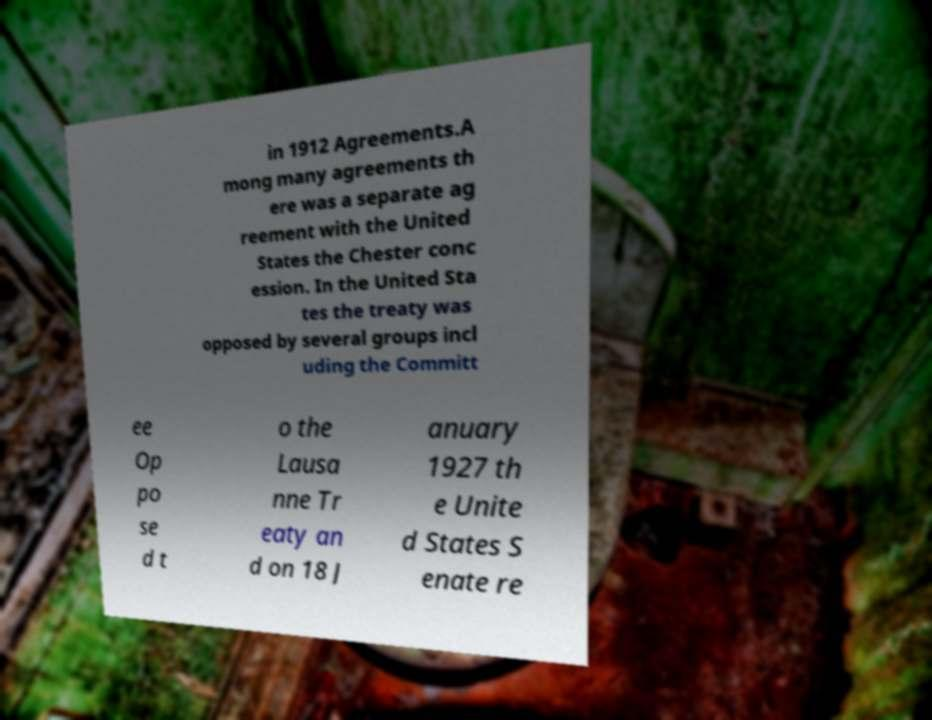What messages or text are displayed in this image? I need them in a readable, typed format. in 1912 Agreements.A mong many agreements th ere was a separate ag reement with the United States the Chester conc ession. In the United Sta tes the treaty was opposed by several groups incl uding the Committ ee Op po se d t o the Lausa nne Tr eaty an d on 18 J anuary 1927 th e Unite d States S enate re 